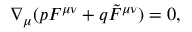Convert formula to latex. <formula><loc_0><loc_0><loc_500><loc_500>\nabla _ { \mu } ( p F ^ { \mu \nu } + q \tilde { F } ^ { \mu \nu } ) = 0 ,</formula> 